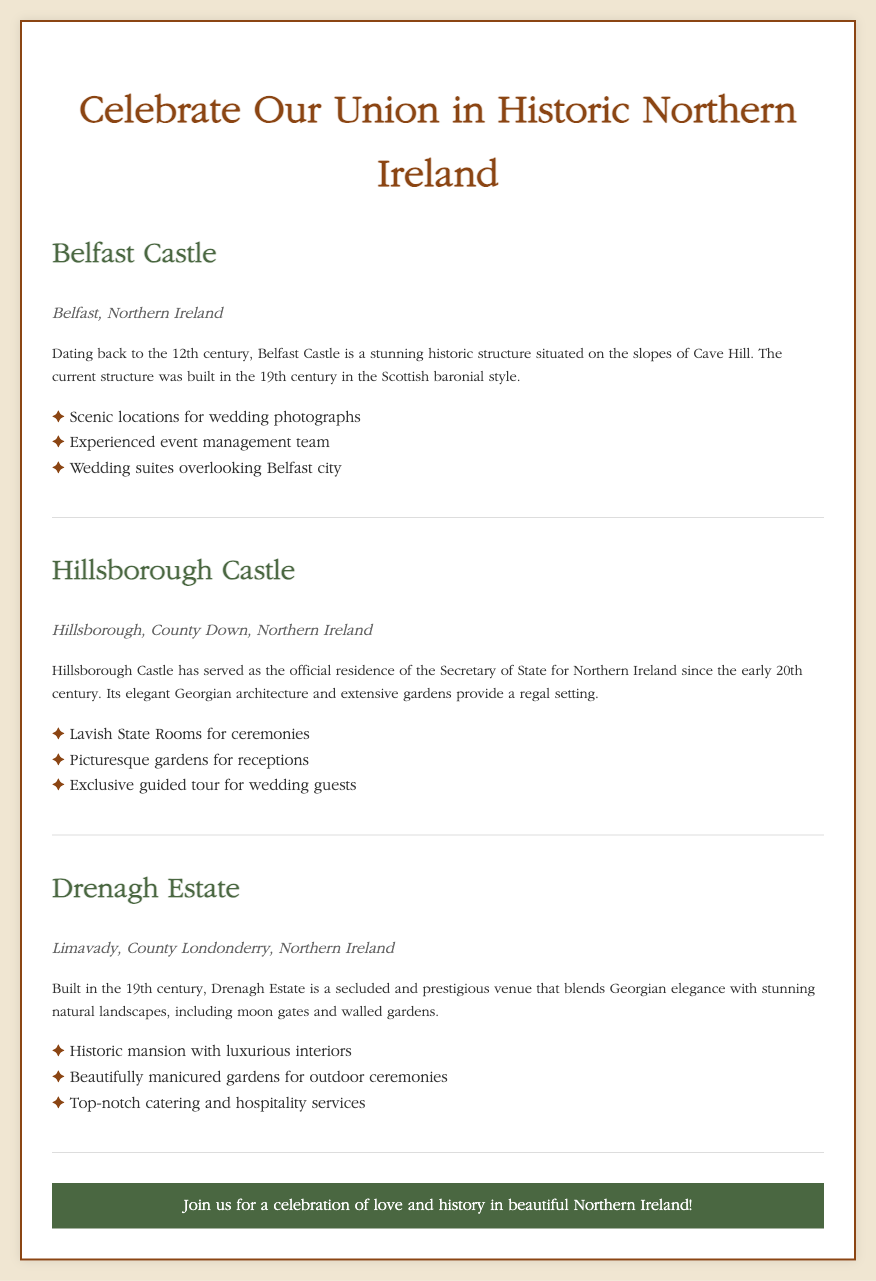What is the name of the historic venue in Belfast? The document mentions "Belfast Castle" as the historic venue located in Belfast.
Answer: Belfast Castle What architectural style is Belfast Castle built in? The document states that Belfast Castle is built in the Scottish baronial style.
Answer: Scottish baronial What is the location of Hillsborough Castle? The document specifies "Hillsborough, County Down, Northern Ireland" as the location of Hillsborough Castle.
Answer: Hillsborough, County Down, Northern Ireland What year did Hillsborough Castle begin serving as the official residence? The document indicates that Hillsborough Castle has served in this capacity since the early 20th century.
Answer: Early 20th century How many features are listed for Drenagh Estate? The document lists three features under Drenagh Estate.
Answer: Three What type of setting does Drenagh Estate provide? The document describes Drenagh Estate as a "secluded and prestigious venue."
Answer: Secluded and prestigious What type of rooms are available for ceremonies at Hillsborough Castle? The document mentions "Lavish State Rooms" as available for ceremonies.
Answer: Lavish State Rooms Which venue is associated with extensive gardens? The document states that "Hillsborough Castle" has extensive gardens.
Answer: Hillsborough Castle What is the design age of Drenagh Estate? The document notes that Drenagh Estate was built in the 19th century.
Answer: 19th century 